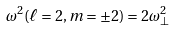Convert formula to latex. <formula><loc_0><loc_0><loc_500><loc_500>\omega ^ { 2 } ( \ell = 2 , m = \pm 2 ) = 2 \omega _ { \perp } ^ { 2 }</formula> 